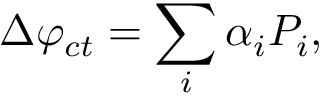<formula> <loc_0><loc_0><loc_500><loc_500>\Delta \varphi _ { c t } = \sum _ { i } { \alpha _ { i } P _ { i } } ,</formula> 